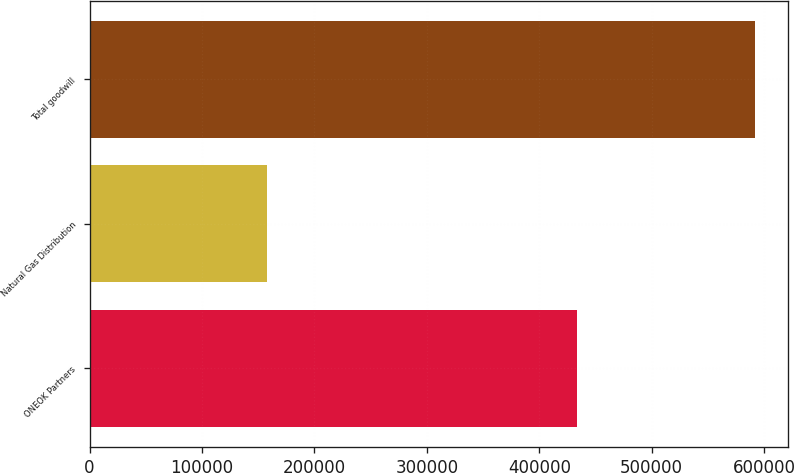<chart> <loc_0><loc_0><loc_500><loc_500><bar_chart><fcel>ONEOK Partners<fcel>Natural Gas Distribution<fcel>Total goodwill<nl><fcel>433535<fcel>157953<fcel>591488<nl></chart> 